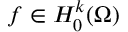Convert formula to latex. <formula><loc_0><loc_0><loc_500><loc_500>f \in H _ { 0 } ^ { k } ( \Omega )</formula> 